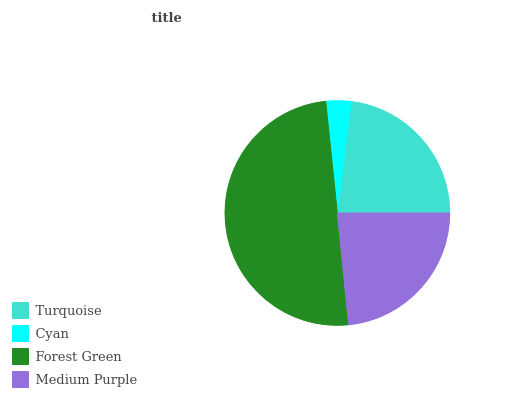Is Cyan the minimum?
Answer yes or no. Yes. Is Forest Green the maximum?
Answer yes or no. Yes. Is Forest Green the minimum?
Answer yes or no. No. Is Cyan the maximum?
Answer yes or no. No. Is Forest Green greater than Cyan?
Answer yes or no. Yes. Is Cyan less than Forest Green?
Answer yes or no. Yes. Is Cyan greater than Forest Green?
Answer yes or no. No. Is Forest Green less than Cyan?
Answer yes or no. No. Is Medium Purple the high median?
Answer yes or no. Yes. Is Turquoise the low median?
Answer yes or no. Yes. Is Cyan the high median?
Answer yes or no. No. Is Medium Purple the low median?
Answer yes or no. No. 